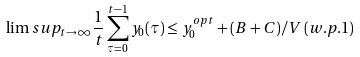Convert formula to latex. <formula><loc_0><loc_0><loc_500><loc_500>\lim s u p _ { t \rightarrow \infty } \frac { 1 } { t } \sum _ { \tau = 0 } ^ { t - 1 } y _ { 0 } ( \tau ) \leq y _ { 0 } ^ { o p t } + ( B + C ) / V \, ( w . p . 1 )</formula> 